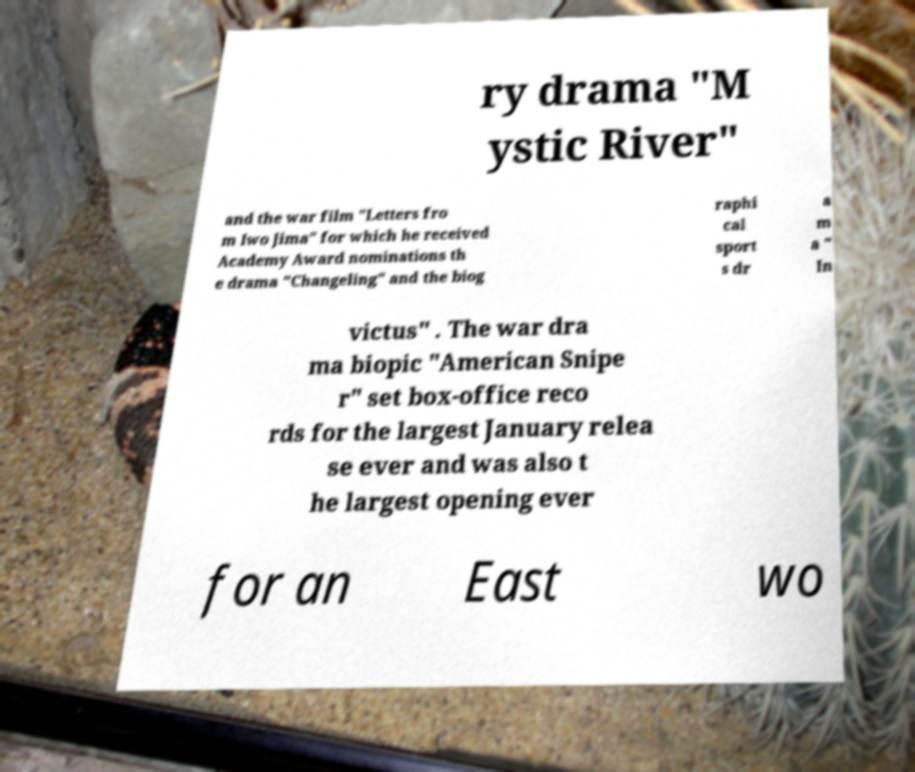Can you read and provide the text displayed in the image?This photo seems to have some interesting text. Can you extract and type it out for me? ry drama "M ystic River" and the war film "Letters fro m Iwo Jima" for which he received Academy Award nominations th e drama "Changeling" and the biog raphi cal sport s dr a m a " In victus" . The war dra ma biopic "American Snipe r" set box-office reco rds for the largest January relea se ever and was also t he largest opening ever for an East wo 